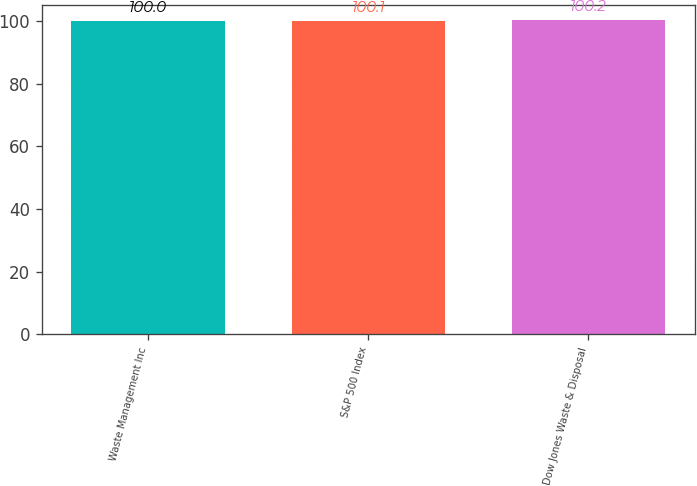Convert chart to OTSL. <chart><loc_0><loc_0><loc_500><loc_500><bar_chart><fcel>Waste Management Inc<fcel>S&P 500 Index<fcel>Dow Jones Waste & Disposal<nl><fcel>100<fcel>100.1<fcel>100.2<nl></chart> 